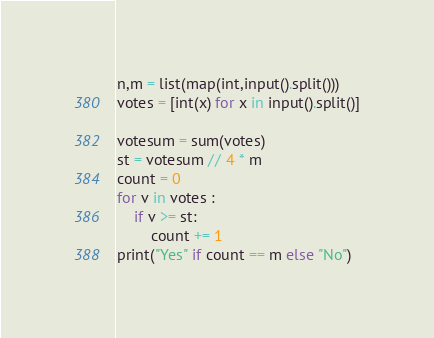Convert code to text. <code><loc_0><loc_0><loc_500><loc_500><_Python_>n,m = list(map(int,input().split()))
votes = [int(x) for x in input().split()]

votesum = sum(votes)
st = votesum // 4 * m
count = 0
for v in votes :
    if v >= st:
        count += 1
print("Yes" if count == m else "No")</code> 